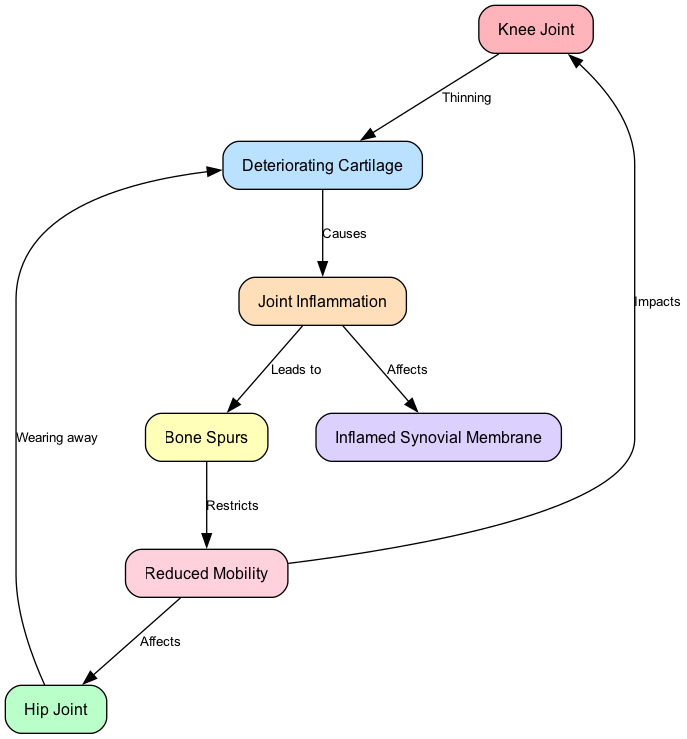What are the two main joints highlighted in the diagram? The diagram specifically identifies the 'Knee Joint' and 'Hip Joint' as the main joints involved in arthritis. These are explicitly labeled as the primary focus areas of the illustration.
Answer: Knee Joint, Hip Joint How many nodes are present in the diagram? The diagram consists of 7 nodes in total, which include the 'Knee Joint', 'Hip Joint', 'Deteriorating Cartilage', 'Joint Inflammation', 'Bone Spurs', 'Inflamed Synovial Membrane', and 'Reduced Mobility'. Counting these labeled components gives us the total.
Answer: 7 What does thinning cartilage in the knee lead to? According to the diagram, thinning cartilage in the knee causes joint inflammation. This is indicated by a directed edge that links the 'Knee Joint' to 'Deteriorating Cartilage' and then to 'Joint Inflammation'.
Answer: Joint Inflammation What type of joint issue is directly caused by inflammation? The diagram illustrates that joint inflammation leads to the formation of 'Bone Spurs'. This connection is defined by an edge labeled ‘Leads to’ from 'Joint Inflammation' to 'Bone Spurs'.
Answer: Bone Spurs Which joint is affected by mobility issues according to the diagram? The diagram indicates that 'Reduced Mobility' impacts both the 'Knee Joint' and 'Hip Joint'. There are directed edges leading from 'Reduced Mobility' to both of these joints, showing that mobility issues affect both areas directly.
Answer: Knee Joint, Hip Joint What is the relationship between inflammation and the synovium? The diagram states that inflammation affects the 'Inflamed Synovial Membrane'. This relationship is represented by an edge labeled 'Affects' that connects 'Joint Inflammation' to 'Inflamed Synovial Membrane'.
Answer: Inflamed Synovial Membrane What restricts mobility according to the diagram? The diagram shows that 'Bone Spurs' restrict mobility. There is a directed connection from 'Bone Spurs' to 'Reduced Mobility', explicitly stating this restriction.
Answer: Bone Spurs Explain the flow from deteriorating cartilage to mobility issues. The flow starts with 'Deteriorating Cartilage', which affects the joint inflammation. From the inflammation, the diagram shows it leads to the formation of 'Bone Spurs'. These bone spurs then restrict mobility, creating a chain of impact from the cartilage condition to reduced mobility.
Answer: Reduced Mobility 